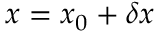Convert formula to latex. <formula><loc_0><loc_0><loc_500><loc_500>x = x _ { 0 } + \delta x</formula> 